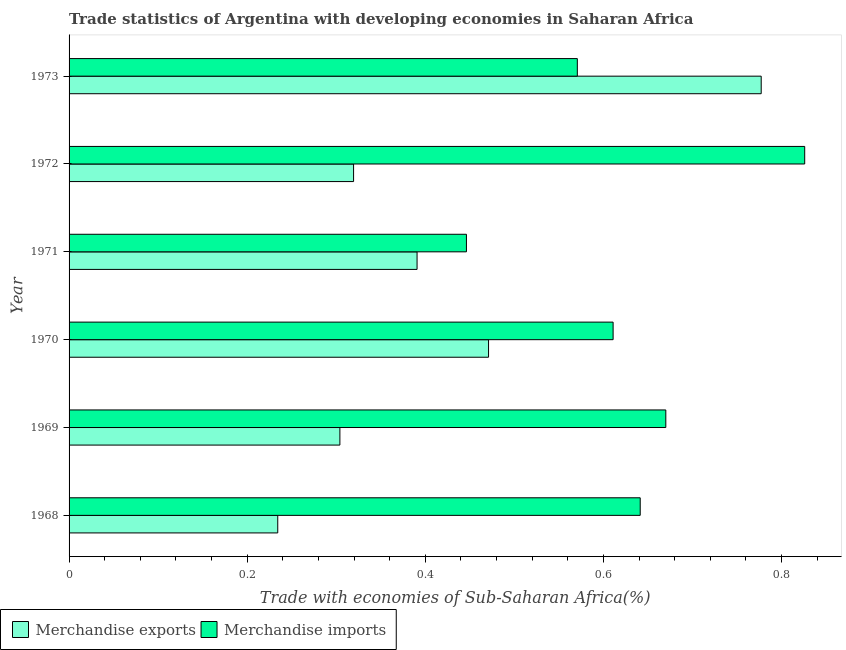Are the number of bars per tick equal to the number of legend labels?
Offer a very short reply. Yes. How many bars are there on the 2nd tick from the bottom?
Your response must be concise. 2. What is the label of the 2nd group of bars from the top?
Give a very brief answer. 1972. In how many cases, is the number of bars for a given year not equal to the number of legend labels?
Ensure brevity in your answer.  0. What is the merchandise imports in 1972?
Offer a terse response. 0.83. Across all years, what is the maximum merchandise imports?
Your answer should be very brief. 0.83. Across all years, what is the minimum merchandise imports?
Your answer should be very brief. 0.45. In which year was the merchandise exports maximum?
Keep it short and to the point. 1973. In which year was the merchandise imports minimum?
Provide a short and direct response. 1971. What is the total merchandise imports in the graph?
Your answer should be very brief. 3.76. What is the difference between the merchandise imports in 1969 and that in 1970?
Offer a very short reply. 0.06. What is the difference between the merchandise exports in 1971 and the merchandise imports in 1968?
Offer a terse response. -0.25. What is the average merchandise exports per year?
Give a very brief answer. 0.42. In the year 1969, what is the difference between the merchandise exports and merchandise imports?
Provide a short and direct response. -0.37. What is the ratio of the merchandise imports in 1969 to that in 1970?
Offer a very short reply. 1.1. What is the difference between the highest and the second highest merchandise imports?
Give a very brief answer. 0.16. What is the difference between the highest and the lowest merchandise exports?
Provide a succinct answer. 0.54. In how many years, is the merchandise imports greater than the average merchandise imports taken over all years?
Keep it short and to the point. 3. Is the sum of the merchandise imports in 1969 and 1972 greater than the maximum merchandise exports across all years?
Offer a terse response. Yes. What does the 2nd bar from the bottom in 1970 represents?
Provide a succinct answer. Merchandise imports. Are all the bars in the graph horizontal?
Give a very brief answer. Yes. How many years are there in the graph?
Offer a terse response. 6. Does the graph contain any zero values?
Ensure brevity in your answer.  No. Does the graph contain grids?
Provide a short and direct response. No. Where does the legend appear in the graph?
Offer a very short reply. Bottom left. How are the legend labels stacked?
Your answer should be very brief. Horizontal. What is the title of the graph?
Your response must be concise. Trade statistics of Argentina with developing economies in Saharan Africa. Does "Male population" appear as one of the legend labels in the graph?
Your answer should be very brief. No. What is the label or title of the X-axis?
Your response must be concise. Trade with economies of Sub-Saharan Africa(%). What is the label or title of the Y-axis?
Provide a succinct answer. Year. What is the Trade with economies of Sub-Saharan Africa(%) of Merchandise exports in 1968?
Provide a succinct answer. 0.23. What is the Trade with economies of Sub-Saharan Africa(%) of Merchandise imports in 1968?
Offer a terse response. 0.64. What is the Trade with economies of Sub-Saharan Africa(%) in Merchandise exports in 1969?
Offer a very short reply. 0.3. What is the Trade with economies of Sub-Saharan Africa(%) in Merchandise imports in 1969?
Provide a short and direct response. 0.67. What is the Trade with economies of Sub-Saharan Africa(%) in Merchandise exports in 1970?
Your answer should be very brief. 0.47. What is the Trade with economies of Sub-Saharan Africa(%) of Merchandise imports in 1970?
Provide a short and direct response. 0.61. What is the Trade with economies of Sub-Saharan Africa(%) of Merchandise exports in 1971?
Provide a short and direct response. 0.39. What is the Trade with economies of Sub-Saharan Africa(%) of Merchandise imports in 1971?
Provide a succinct answer. 0.45. What is the Trade with economies of Sub-Saharan Africa(%) in Merchandise exports in 1972?
Ensure brevity in your answer.  0.32. What is the Trade with economies of Sub-Saharan Africa(%) in Merchandise imports in 1972?
Provide a short and direct response. 0.83. What is the Trade with economies of Sub-Saharan Africa(%) of Merchandise exports in 1973?
Provide a succinct answer. 0.78. What is the Trade with economies of Sub-Saharan Africa(%) of Merchandise imports in 1973?
Ensure brevity in your answer.  0.57. Across all years, what is the maximum Trade with economies of Sub-Saharan Africa(%) in Merchandise exports?
Provide a succinct answer. 0.78. Across all years, what is the maximum Trade with economies of Sub-Saharan Africa(%) of Merchandise imports?
Ensure brevity in your answer.  0.83. Across all years, what is the minimum Trade with economies of Sub-Saharan Africa(%) in Merchandise exports?
Give a very brief answer. 0.23. Across all years, what is the minimum Trade with economies of Sub-Saharan Africa(%) in Merchandise imports?
Make the answer very short. 0.45. What is the total Trade with economies of Sub-Saharan Africa(%) in Merchandise exports in the graph?
Give a very brief answer. 2.5. What is the total Trade with economies of Sub-Saharan Africa(%) in Merchandise imports in the graph?
Keep it short and to the point. 3.76. What is the difference between the Trade with economies of Sub-Saharan Africa(%) in Merchandise exports in 1968 and that in 1969?
Offer a terse response. -0.07. What is the difference between the Trade with economies of Sub-Saharan Africa(%) in Merchandise imports in 1968 and that in 1969?
Your response must be concise. -0.03. What is the difference between the Trade with economies of Sub-Saharan Africa(%) in Merchandise exports in 1968 and that in 1970?
Provide a succinct answer. -0.24. What is the difference between the Trade with economies of Sub-Saharan Africa(%) in Merchandise imports in 1968 and that in 1970?
Your answer should be very brief. 0.03. What is the difference between the Trade with economies of Sub-Saharan Africa(%) of Merchandise exports in 1968 and that in 1971?
Your answer should be very brief. -0.16. What is the difference between the Trade with economies of Sub-Saharan Africa(%) of Merchandise imports in 1968 and that in 1971?
Ensure brevity in your answer.  0.2. What is the difference between the Trade with economies of Sub-Saharan Africa(%) of Merchandise exports in 1968 and that in 1972?
Ensure brevity in your answer.  -0.09. What is the difference between the Trade with economies of Sub-Saharan Africa(%) in Merchandise imports in 1968 and that in 1972?
Offer a very short reply. -0.18. What is the difference between the Trade with economies of Sub-Saharan Africa(%) in Merchandise exports in 1968 and that in 1973?
Your response must be concise. -0.54. What is the difference between the Trade with economies of Sub-Saharan Africa(%) of Merchandise imports in 1968 and that in 1973?
Provide a short and direct response. 0.07. What is the difference between the Trade with economies of Sub-Saharan Africa(%) of Merchandise exports in 1969 and that in 1970?
Provide a short and direct response. -0.17. What is the difference between the Trade with economies of Sub-Saharan Africa(%) in Merchandise imports in 1969 and that in 1970?
Offer a very short reply. 0.06. What is the difference between the Trade with economies of Sub-Saharan Africa(%) of Merchandise exports in 1969 and that in 1971?
Provide a succinct answer. -0.09. What is the difference between the Trade with economies of Sub-Saharan Africa(%) in Merchandise imports in 1969 and that in 1971?
Offer a very short reply. 0.22. What is the difference between the Trade with economies of Sub-Saharan Africa(%) of Merchandise exports in 1969 and that in 1972?
Your response must be concise. -0.02. What is the difference between the Trade with economies of Sub-Saharan Africa(%) of Merchandise imports in 1969 and that in 1972?
Your answer should be very brief. -0.16. What is the difference between the Trade with economies of Sub-Saharan Africa(%) of Merchandise exports in 1969 and that in 1973?
Keep it short and to the point. -0.47. What is the difference between the Trade with economies of Sub-Saharan Africa(%) of Merchandise imports in 1969 and that in 1973?
Provide a short and direct response. 0.1. What is the difference between the Trade with economies of Sub-Saharan Africa(%) of Merchandise exports in 1970 and that in 1971?
Keep it short and to the point. 0.08. What is the difference between the Trade with economies of Sub-Saharan Africa(%) in Merchandise imports in 1970 and that in 1971?
Provide a short and direct response. 0.16. What is the difference between the Trade with economies of Sub-Saharan Africa(%) in Merchandise exports in 1970 and that in 1972?
Give a very brief answer. 0.15. What is the difference between the Trade with economies of Sub-Saharan Africa(%) of Merchandise imports in 1970 and that in 1972?
Your response must be concise. -0.22. What is the difference between the Trade with economies of Sub-Saharan Africa(%) in Merchandise exports in 1970 and that in 1973?
Ensure brevity in your answer.  -0.31. What is the difference between the Trade with economies of Sub-Saharan Africa(%) of Merchandise imports in 1970 and that in 1973?
Offer a very short reply. 0.04. What is the difference between the Trade with economies of Sub-Saharan Africa(%) of Merchandise exports in 1971 and that in 1972?
Ensure brevity in your answer.  0.07. What is the difference between the Trade with economies of Sub-Saharan Africa(%) in Merchandise imports in 1971 and that in 1972?
Offer a terse response. -0.38. What is the difference between the Trade with economies of Sub-Saharan Africa(%) in Merchandise exports in 1971 and that in 1973?
Make the answer very short. -0.39. What is the difference between the Trade with economies of Sub-Saharan Africa(%) of Merchandise imports in 1971 and that in 1973?
Provide a succinct answer. -0.12. What is the difference between the Trade with economies of Sub-Saharan Africa(%) of Merchandise exports in 1972 and that in 1973?
Offer a terse response. -0.46. What is the difference between the Trade with economies of Sub-Saharan Africa(%) of Merchandise imports in 1972 and that in 1973?
Offer a terse response. 0.26. What is the difference between the Trade with economies of Sub-Saharan Africa(%) of Merchandise exports in 1968 and the Trade with economies of Sub-Saharan Africa(%) of Merchandise imports in 1969?
Ensure brevity in your answer.  -0.44. What is the difference between the Trade with economies of Sub-Saharan Africa(%) of Merchandise exports in 1968 and the Trade with economies of Sub-Saharan Africa(%) of Merchandise imports in 1970?
Provide a short and direct response. -0.38. What is the difference between the Trade with economies of Sub-Saharan Africa(%) in Merchandise exports in 1968 and the Trade with economies of Sub-Saharan Africa(%) in Merchandise imports in 1971?
Ensure brevity in your answer.  -0.21. What is the difference between the Trade with economies of Sub-Saharan Africa(%) in Merchandise exports in 1968 and the Trade with economies of Sub-Saharan Africa(%) in Merchandise imports in 1972?
Ensure brevity in your answer.  -0.59. What is the difference between the Trade with economies of Sub-Saharan Africa(%) of Merchandise exports in 1968 and the Trade with economies of Sub-Saharan Africa(%) of Merchandise imports in 1973?
Keep it short and to the point. -0.34. What is the difference between the Trade with economies of Sub-Saharan Africa(%) of Merchandise exports in 1969 and the Trade with economies of Sub-Saharan Africa(%) of Merchandise imports in 1970?
Give a very brief answer. -0.31. What is the difference between the Trade with economies of Sub-Saharan Africa(%) in Merchandise exports in 1969 and the Trade with economies of Sub-Saharan Africa(%) in Merchandise imports in 1971?
Provide a short and direct response. -0.14. What is the difference between the Trade with economies of Sub-Saharan Africa(%) of Merchandise exports in 1969 and the Trade with economies of Sub-Saharan Africa(%) of Merchandise imports in 1972?
Ensure brevity in your answer.  -0.52. What is the difference between the Trade with economies of Sub-Saharan Africa(%) of Merchandise exports in 1969 and the Trade with economies of Sub-Saharan Africa(%) of Merchandise imports in 1973?
Give a very brief answer. -0.27. What is the difference between the Trade with economies of Sub-Saharan Africa(%) of Merchandise exports in 1970 and the Trade with economies of Sub-Saharan Africa(%) of Merchandise imports in 1971?
Offer a very short reply. 0.02. What is the difference between the Trade with economies of Sub-Saharan Africa(%) in Merchandise exports in 1970 and the Trade with economies of Sub-Saharan Africa(%) in Merchandise imports in 1972?
Your response must be concise. -0.35. What is the difference between the Trade with economies of Sub-Saharan Africa(%) of Merchandise exports in 1970 and the Trade with economies of Sub-Saharan Africa(%) of Merchandise imports in 1973?
Your response must be concise. -0.1. What is the difference between the Trade with economies of Sub-Saharan Africa(%) of Merchandise exports in 1971 and the Trade with economies of Sub-Saharan Africa(%) of Merchandise imports in 1972?
Make the answer very short. -0.44. What is the difference between the Trade with economies of Sub-Saharan Africa(%) of Merchandise exports in 1971 and the Trade with economies of Sub-Saharan Africa(%) of Merchandise imports in 1973?
Make the answer very short. -0.18. What is the difference between the Trade with economies of Sub-Saharan Africa(%) in Merchandise exports in 1972 and the Trade with economies of Sub-Saharan Africa(%) in Merchandise imports in 1973?
Ensure brevity in your answer.  -0.25. What is the average Trade with economies of Sub-Saharan Africa(%) of Merchandise exports per year?
Ensure brevity in your answer.  0.42. What is the average Trade with economies of Sub-Saharan Africa(%) in Merchandise imports per year?
Your answer should be very brief. 0.63. In the year 1968, what is the difference between the Trade with economies of Sub-Saharan Africa(%) of Merchandise exports and Trade with economies of Sub-Saharan Africa(%) of Merchandise imports?
Your answer should be compact. -0.41. In the year 1969, what is the difference between the Trade with economies of Sub-Saharan Africa(%) of Merchandise exports and Trade with economies of Sub-Saharan Africa(%) of Merchandise imports?
Provide a succinct answer. -0.37. In the year 1970, what is the difference between the Trade with economies of Sub-Saharan Africa(%) of Merchandise exports and Trade with economies of Sub-Saharan Africa(%) of Merchandise imports?
Make the answer very short. -0.14. In the year 1971, what is the difference between the Trade with economies of Sub-Saharan Africa(%) of Merchandise exports and Trade with economies of Sub-Saharan Africa(%) of Merchandise imports?
Offer a very short reply. -0.06. In the year 1972, what is the difference between the Trade with economies of Sub-Saharan Africa(%) of Merchandise exports and Trade with economies of Sub-Saharan Africa(%) of Merchandise imports?
Ensure brevity in your answer.  -0.51. In the year 1973, what is the difference between the Trade with economies of Sub-Saharan Africa(%) in Merchandise exports and Trade with economies of Sub-Saharan Africa(%) in Merchandise imports?
Give a very brief answer. 0.21. What is the ratio of the Trade with economies of Sub-Saharan Africa(%) in Merchandise exports in 1968 to that in 1969?
Your answer should be very brief. 0.77. What is the ratio of the Trade with economies of Sub-Saharan Africa(%) of Merchandise imports in 1968 to that in 1969?
Give a very brief answer. 0.96. What is the ratio of the Trade with economies of Sub-Saharan Africa(%) in Merchandise exports in 1968 to that in 1970?
Make the answer very short. 0.5. What is the ratio of the Trade with economies of Sub-Saharan Africa(%) of Merchandise imports in 1968 to that in 1970?
Your response must be concise. 1.05. What is the ratio of the Trade with economies of Sub-Saharan Africa(%) in Merchandise exports in 1968 to that in 1971?
Your answer should be very brief. 0.6. What is the ratio of the Trade with economies of Sub-Saharan Africa(%) of Merchandise imports in 1968 to that in 1971?
Offer a very short reply. 1.44. What is the ratio of the Trade with economies of Sub-Saharan Africa(%) of Merchandise exports in 1968 to that in 1972?
Offer a terse response. 0.73. What is the ratio of the Trade with economies of Sub-Saharan Africa(%) of Merchandise imports in 1968 to that in 1972?
Ensure brevity in your answer.  0.78. What is the ratio of the Trade with economies of Sub-Saharan Africa(%) in Merchandise exports in 1968 to that in 1973?
Offer a terse response. 0.3. What is the ratio of the Trade with economies of Sub-Saharan Africa(%) of Merchandise imports in 1968 to that in 1973?
Give a very brief answer. 1.12. What is the ratio of the Trade with economies of Sub-Saharan Africa(%) in Merchandise exports in 1969 to that in 1970?
Ensure brevity in your answer.  0.65. What is the ratio of the Trade with economies of Sub-Saharan Africa(%) in Merchandise imports in 1969 to that in 1970?
Give a very brief answer. 1.1. What is the ratio of the Trade with economies of Sub-Saharan Africa(%) of Merchandise exports in 1969 to that in 1971?
Make the answer very short. 0.78. What is the ratio of the Trade with economies of Sub-Saharan Africa(%) of Merchandise imports in 1969 to that in 1971?
Your response must be concise. 1.5. What is the ratio of the Trade with economies of Sub-Saharan Africa(%) in Merchandise exports in 1969 to that in 1972?
Your response must be concise. 0.95. What is the ratio of the Trade with economies of Sub-Saharan Africa(%) of Merchandise imports in 1969 to that in 1972?
Provide a short and direct response. 0.81. What is the ratio of the Trade with economies of Sub-Saharan Africa(%) in Merchandise exports in 1969 to that in 1973?
Offer a very short reply. 0.39. What is the ratio of the Trade with economies of Sub-Saharan Africa(%) in Merchandise imports in 1969 to that in 1973?
Keep it short and to the point. 1.17. What is the ratio of the Trade with economies of Sub-Saharan Africa(%) of Merchandise exports in 1970 to that in 1971?
Your answer should be compact. 1.21. What is the ratio of the Trade with economies of Sub-Saharan Africa(%) in Merchandise imports in 1970 to that in 1971?
Provide a short and direct response. 1.37. What is the ratio of the Trade with economies of Sub-Saharan Africa(%) in Merchandise exports in 1970 to that in 1972?
Your response must be concise. 1.47. What is the ratio of the Trade with economies of Sub-Saharan Africa(%) of Merchandise imports in 1970 to that in 1972?
Provide a succinct answer. 0.74. What is the ratio of the Trade with economies of Sub-Saharan Africa(%) of Merchandise exports in 1970 to that in 1973?
Provide a succinct answer. 0.61. What is the ratio of the Trade with economies of Sub-Saharan Africa(%) in Merchandise imports in 1970 to that in 1973?
Ensure brevity in your answer.  1.07. What is the ratio of the Trade with economies of Sub-Saharan Africa(%) in Merchandise exports in 1971 to that in 1972?
Offer a terse response. 1.22. What is the ratio of the Trade with economies of Sub-Saharan Africa(%) in Merchandise imports in 1971 to that in 1972?
Make the answer very short. 0.54. What is the ratio of the Trade with economies of Sub-Saharan Africa(%) of Merchandise exports in 1971 to that in 1973?
Ensure brevity in your answer.  0.5. What is the ratio of the Trade with economies of Sub-Saharan Africa(%) of Merchandise imports in 1971 to that in 1973?
Keep it short and to the point. 0.78. What is the ratio of the Trade with economies of Sub-Saharan Africa(%) of Merchandise exports in 1972 to that in 1973?
Your answer should be compact. 0.41. What is the ratio of the Trade with economies of Sub-Saharan Africa(%) of Merchandise imports in 1972 to that in 1973?
Provide a succinct answer. 1.45. What is the difference between the highest and the second highest Trade with economies of Sub-Saharan Africa(%) of Merchandise exports?
Make the answer very short. 0.31. What is the difference between the highest and the second highest Trade with economies of Sub-Saharan Africa(%) of Merchandise imports?
Your response must be concise. 0.16. What is the difference between the highest and the lowest Trade with economies of Sub-Saharan Africa(%) of Merchandise exports?
Your response must be concise. 0.54. What is the difference between the highest and the lowest Trade with economies of Sub-Saharan Africa(%) in Merchandise imports?
Provide a short and direct response. 0.38. 